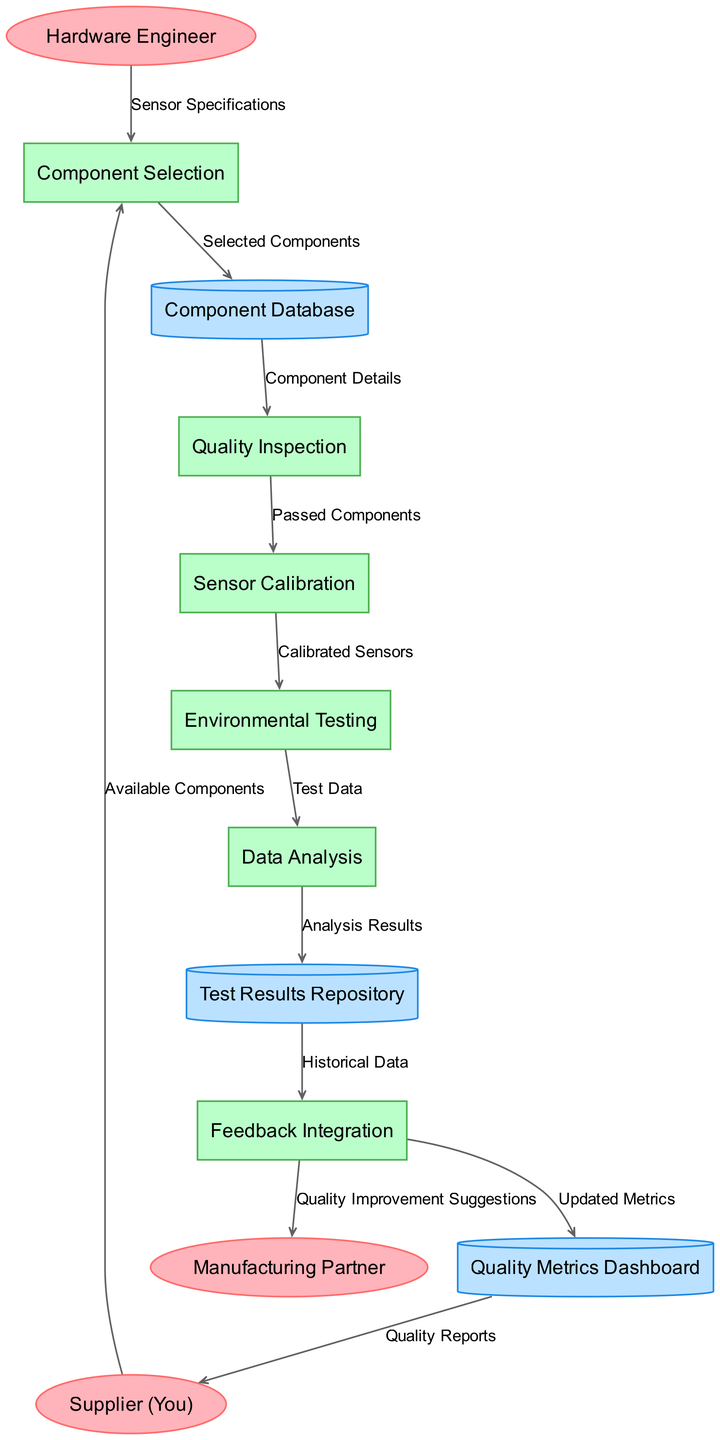What are the external entities in the diagram? The external entities are clearly listed at the start of the diagram. They include "Hardware Engineer," "Supplier (You)," and "Manufacturing Partner."
Answer: Hardware Engineer, Supplier (You), Manufacturing Partner How many processes are represented in the diagram? I can count the processes listed in the diagram which are "Component Selection," "Quality Inspection," "Sensor Calibration," "Environmental Testing," "Data Analysis," and "Feedback Integration." There are six processes in total.
Answer: 6 Which process comes after Quality Inspection? By looking at the flow, after "Quality Inspection," the next process indicated is "Sensor Calibration." This is evident from the directed flow in the diagram.
Answer: Sensor Calibration What is the data flow from Environmental Testing to Data Analysis? The diagram indicates that the data flow labeled "Test Data" goes from "Environmental Testing" to "Data Analysis." This flow shows the specific information being transferred between these two processes.
Answer: Test Data Who receives the Quality Improvement Suggestions from Feedback Integration? Based on the diagram's flow, "Feedback Integration" sends "Quality Improvement Suggestions" to the "Manufacturing Partner." This is a direct connection illustrated in the data flow.
Answer: Manufacturing Partner What does the Quality Metrics Dashboard provide to the Supplier? The flow indicates that the "Quality Metrics Dashboard" provides "Quality Reports" to the "Supplier (You)." This describes the information exchanged between these two nodes.
Answer: Quality Reports How many data stores are depicted in the diagram? Counting the data stores, there are "Component Database," "Test Results Repository," and "Quality Metrics Dashboard." Therefore, there are three data stores represented in the diagram.
Answer: 3 What information is sent from Data Analysis to Test Results Repository? The flow shows that "Analysis Results" is sent from "Data Analysis" to "Test Results Repository." This indicates the type of output being stored after the analysis is performed.
Answer: Analysis Results What does Feedback Integration update? The diagram shows that "Feedback Integration" updates the "Quality Metrics Dashboard" with "Updated Metrics." This is a flow that represents how feedback affects quality metrics.
Answer: Updated Metrics Which process precedes Environmental Testing? Looking at the diagram, "Sensor Calibration" is the process that precedes "Environmental Testing," as indicated by the directed flow leading into Environmental Testing.
Answer: Sensor Calibration 